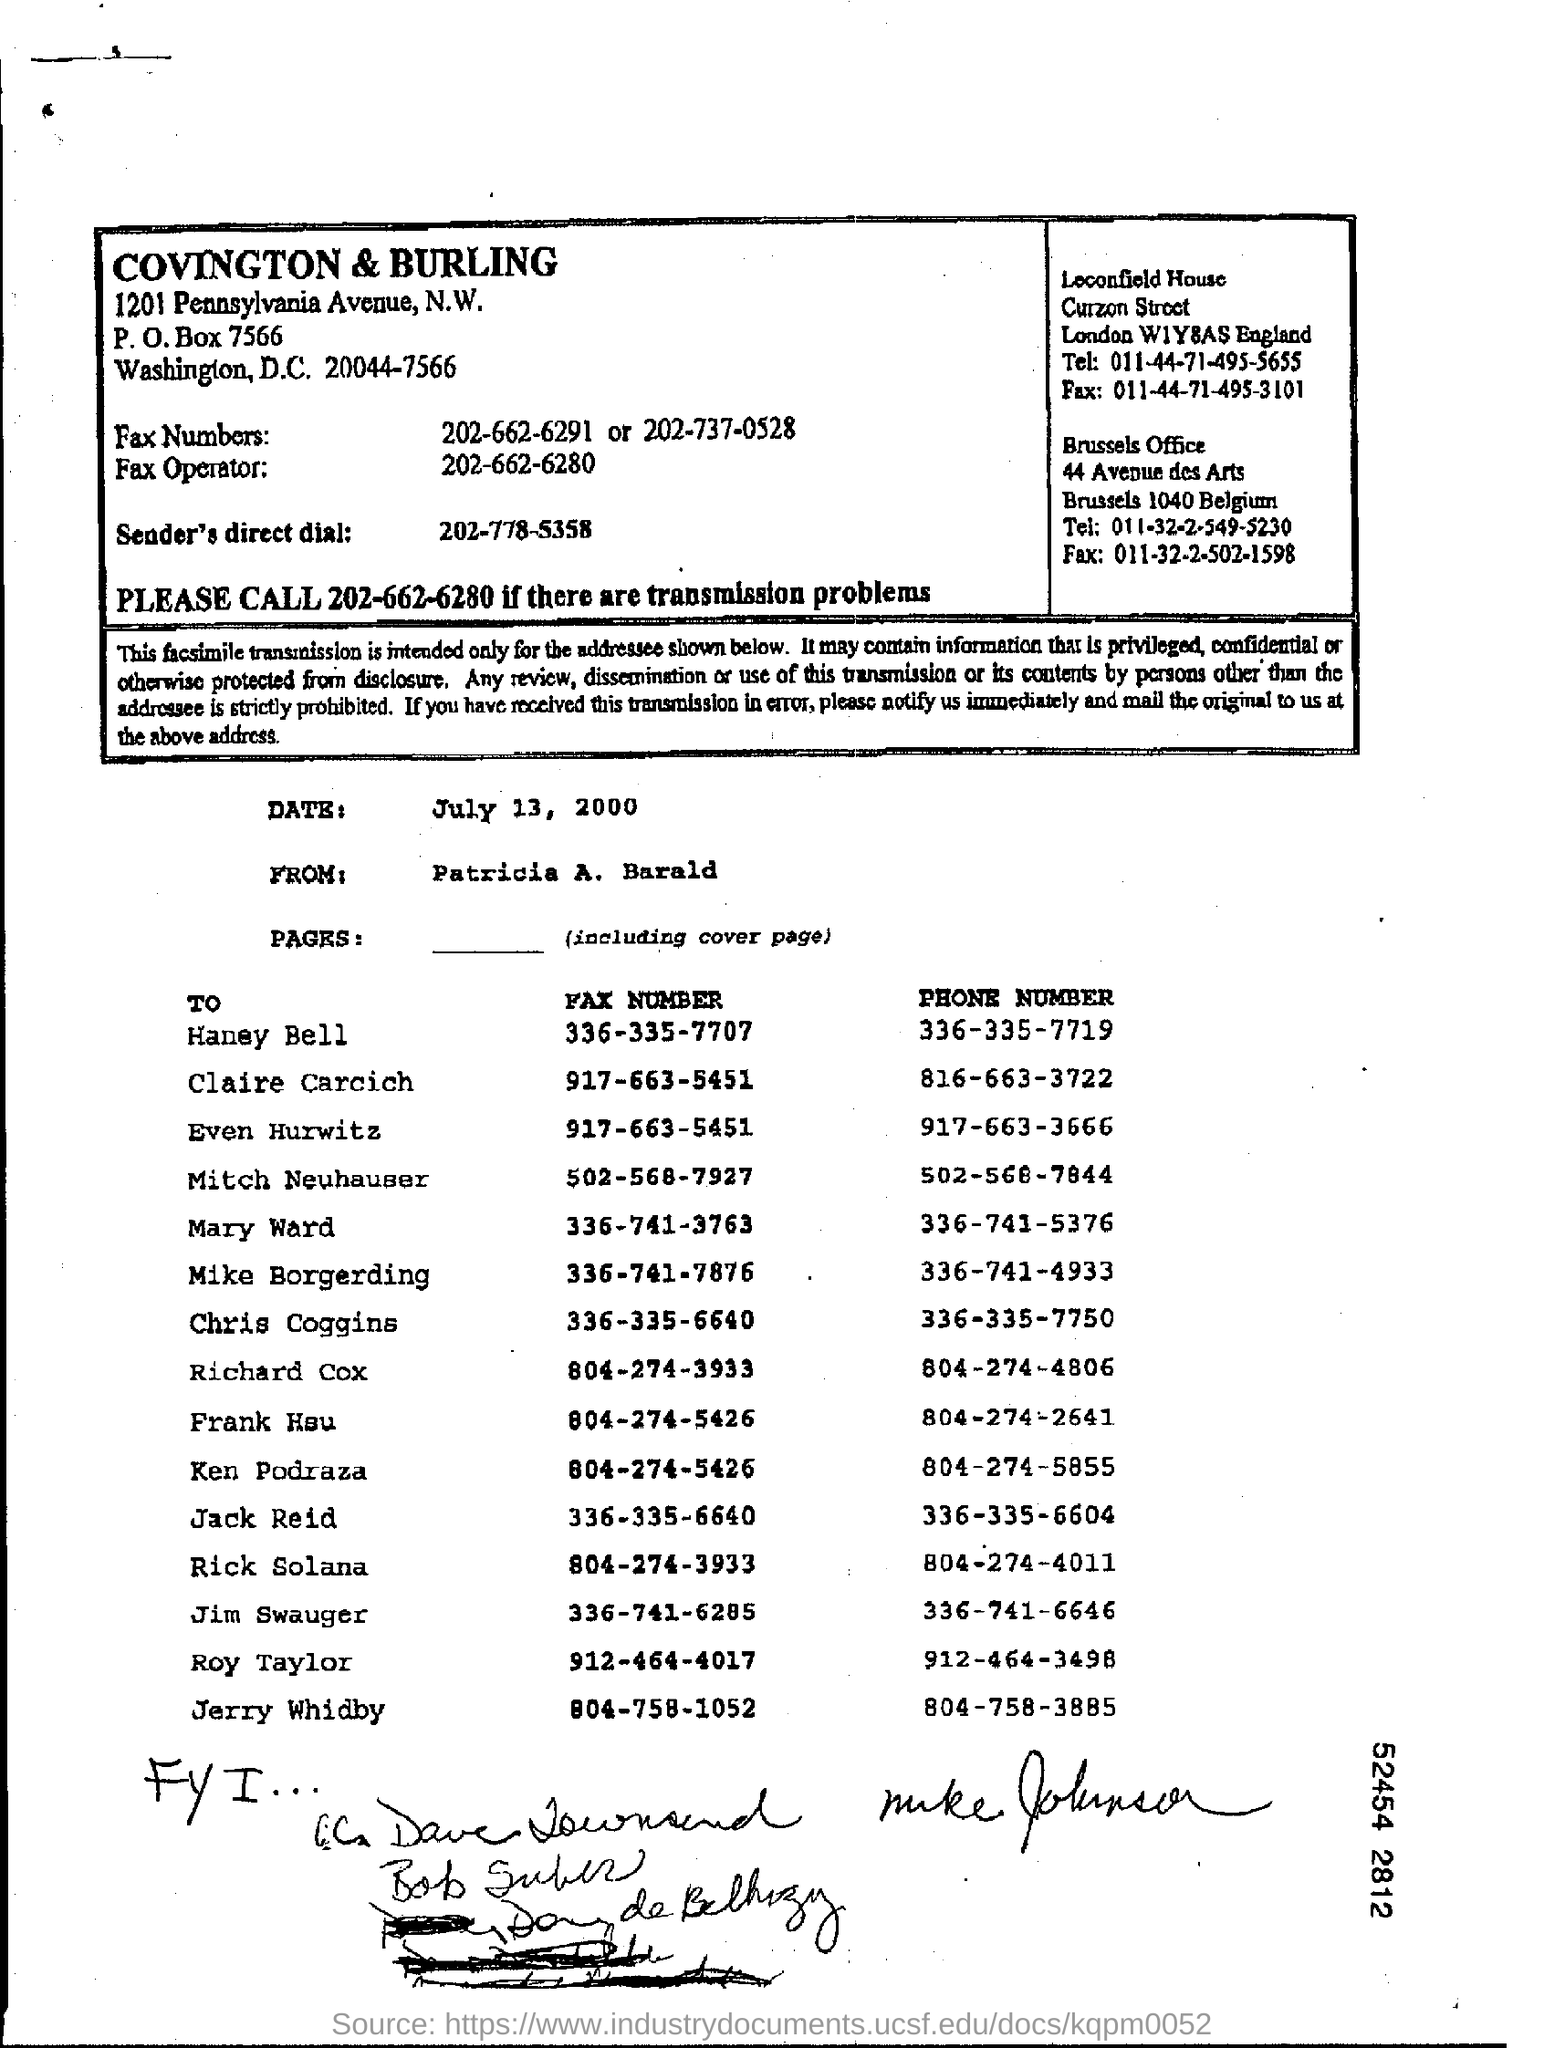Specify some key components in this picture. The fax number of Haney Bell is 336-335-7707. The phone number of Haney Bell is 336-335-7719. The date mentioned is July 13. 